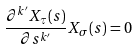<formula> <loc_0><loc_0><loc_500><loc_500>\frac { \partial ^ { k ^ { \prime } } X _ { \tau } ( s ) } { \partial s ^ { k ^ { \prime } } } X _ { \sigma } ( s ) = 0</formula> 